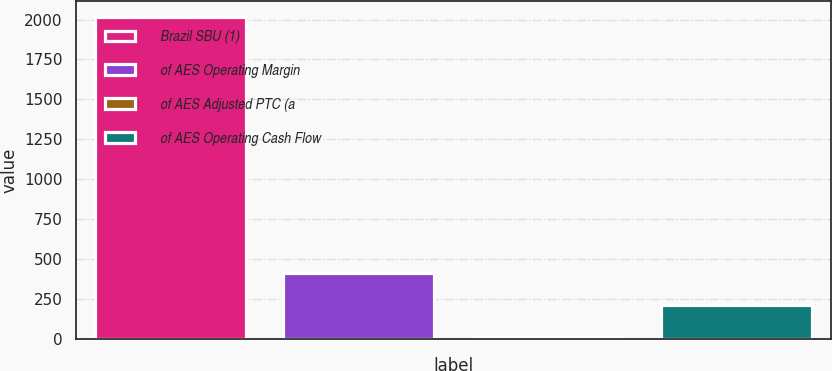Convert chart to OTSL. <chart><loc_0><loc_0><loc_500><loc_500><bar_chart><fcel>Brazil SBU (1)<fcel>of AES Operating Margin<fcel>of AES Adjusted PTC (a<fcel>of AES Operating Cash Flow<nl><fcel>2014<fcel>413.2<fcel>13<fcel>213.1<nl></chart> 